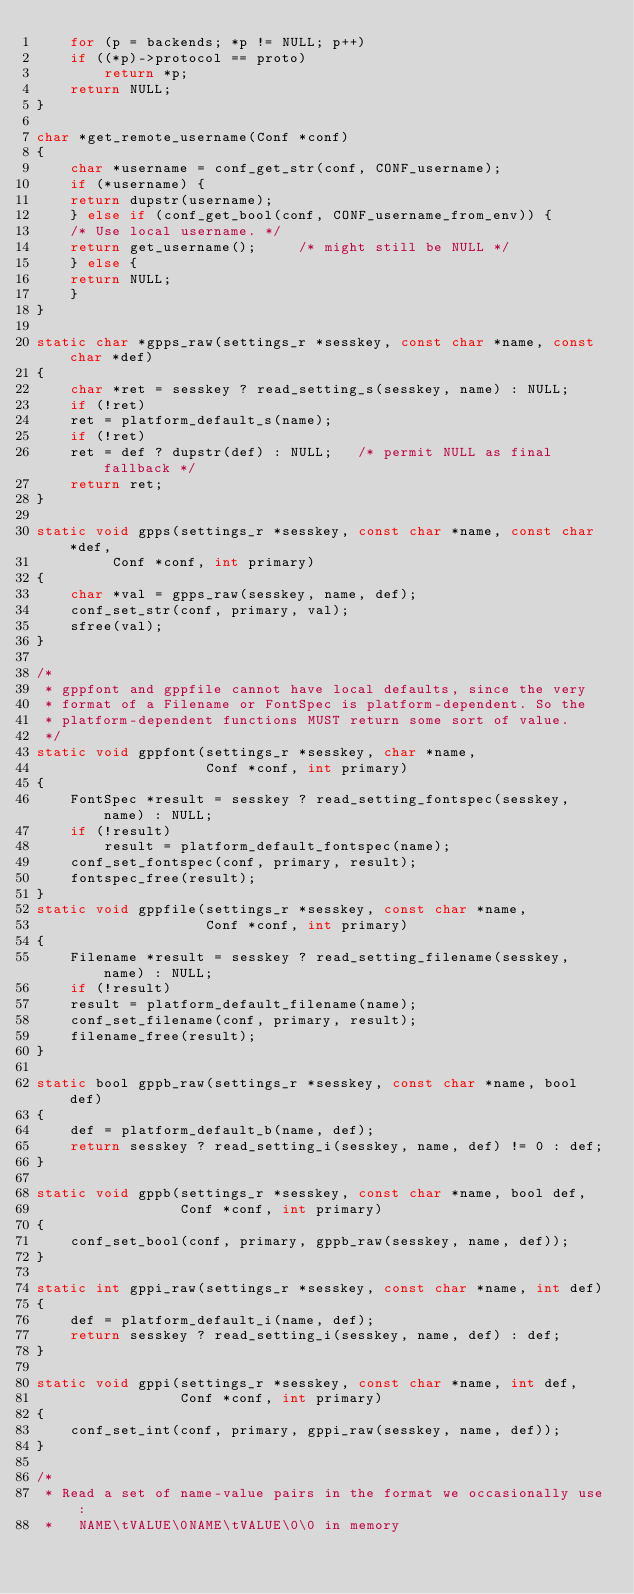<code> <loc_0><loc_0><loc_500><loc_500><_C_>    for (p = backends; *p != NULL; p++)
	if ((*p)->protocol == proto)
	    return *p;
    return NULL;
}

char *get_remote_username(Conf *conf)
{
    char *username = conf_get_str(conf, CONF_username);
    if (*username) {
	return dupstr(username);
    } else if (conf_get_bool(conf, CONF_username_from_env)) {
	/* Use local username. */
	return get_username();     /* might still be NULL */
    } else {
	return NULL;
    }
}

static char *gpps_raw(settings_r *sesskey, const char *name, const char *def)
{
    char *ret = sesskey ? read_setting_s(sesskey, name) : NULL;
    if (!ret)
	ret = platform_default_s(name);
    if (!ret)
	ret = def ? dupstr(def) : NULL;   /* permit NULL as final fallback */
    return ret;
}

static void gpps(settings_r *sesskey, const char *name, const char *def,
		 Conf *conf, int primary)
{
    char *val = gpps_raw(sesskey, name, def);
    conf_set_str(conf, primary, val);
    sfree(val);
}

/*
 * gppfont and gppfile cannot have local defaults, since the very
 * format of a Filename or FontSpec is platform-dependent. So the
 * platform-dependent functions MUST return some sort of value.
 */
static void gppfont(settings_r *sesskey, char *name,
                    Conf *conf, int primary)
{
    FontSpec *result = sesskey ? read_setting_fontspec(sesskey, name) : NULL;
    if (!result)
        result = platform_default_fontspec(name);
    conf_set_fontspec(conf, primary, result);
    fontspec_free(result);
}
static void gppfile(settings_r *sesskey, const char *name,
                    Conf *conf, int primary)
{
    Filename *result = sesskey ? read_setting_filename(sesskey, name) : NULL;
    if (!result)
	result = platform_default_filename(name);
    conf_set_filename(conf, primary, result);
    filename_free(result);
}

static bool gppb_raw(settings_r *sesskey, const char *name, bool def)
{
    def = platform_default_b(name, def);
    return sesskey ? read_setting_i(sesskey, name, def) != 0 : def;
}

static void gppb(settings_r *sesskey, const char *name, bool def,
                 Conf *conf, int primary)
{
    conf_set_bool(conf, primary, gppb_raw(sesskey, name, def));
}

static int gppi_raw(settings_r *sesskey, const char *name, int def)
{
    def = platform_default_i(name, def);
    return sesskey ? read_setting_i(sesskey, name, def) : def;
}

static void gppi(settings_r *sesskey, const char *name, int def,
                 Conf *conf, int primary)
{
    conf_set_int(conf, primary, gppi_raw(sesskey, name, def));
}

/*
 * Read a set of name-value pairs in the format we occasionally use:
 *   NAME\tVALUE\0NAME\tVALUE\0\0 in memory</code> 